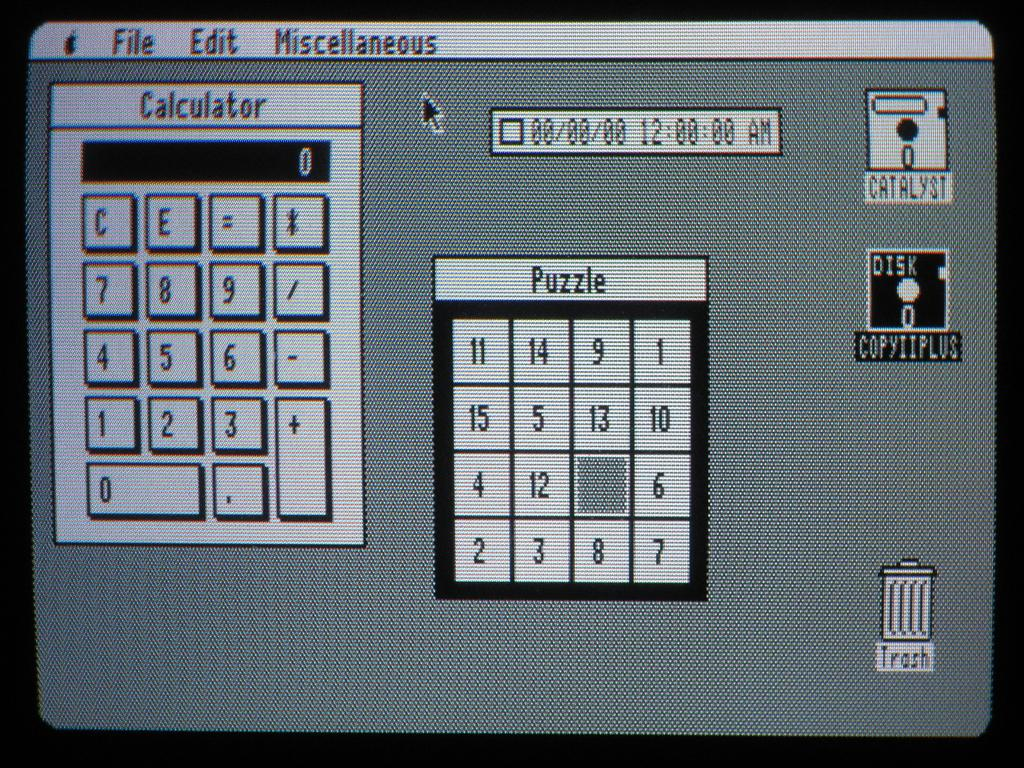<image>
Relay a brief, clear account of the picture shown. Calculator and Puzzle that is on a computer screen. 